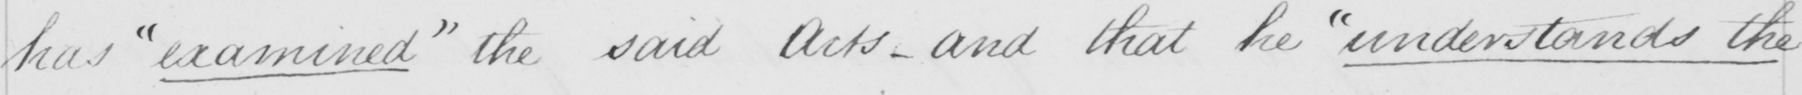Can you tell me what this handwritten text says? has  " examined "  the said Acts  _  and that he  " understands the 